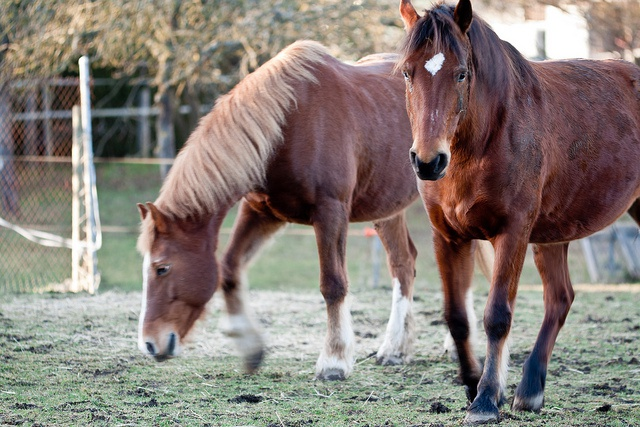Describe the objects in this image and their specific colors. I can see horse in tan, brown, darkgray, gray, and maroon tones and horse in tan, brown, maroon, and black tones in this image. 